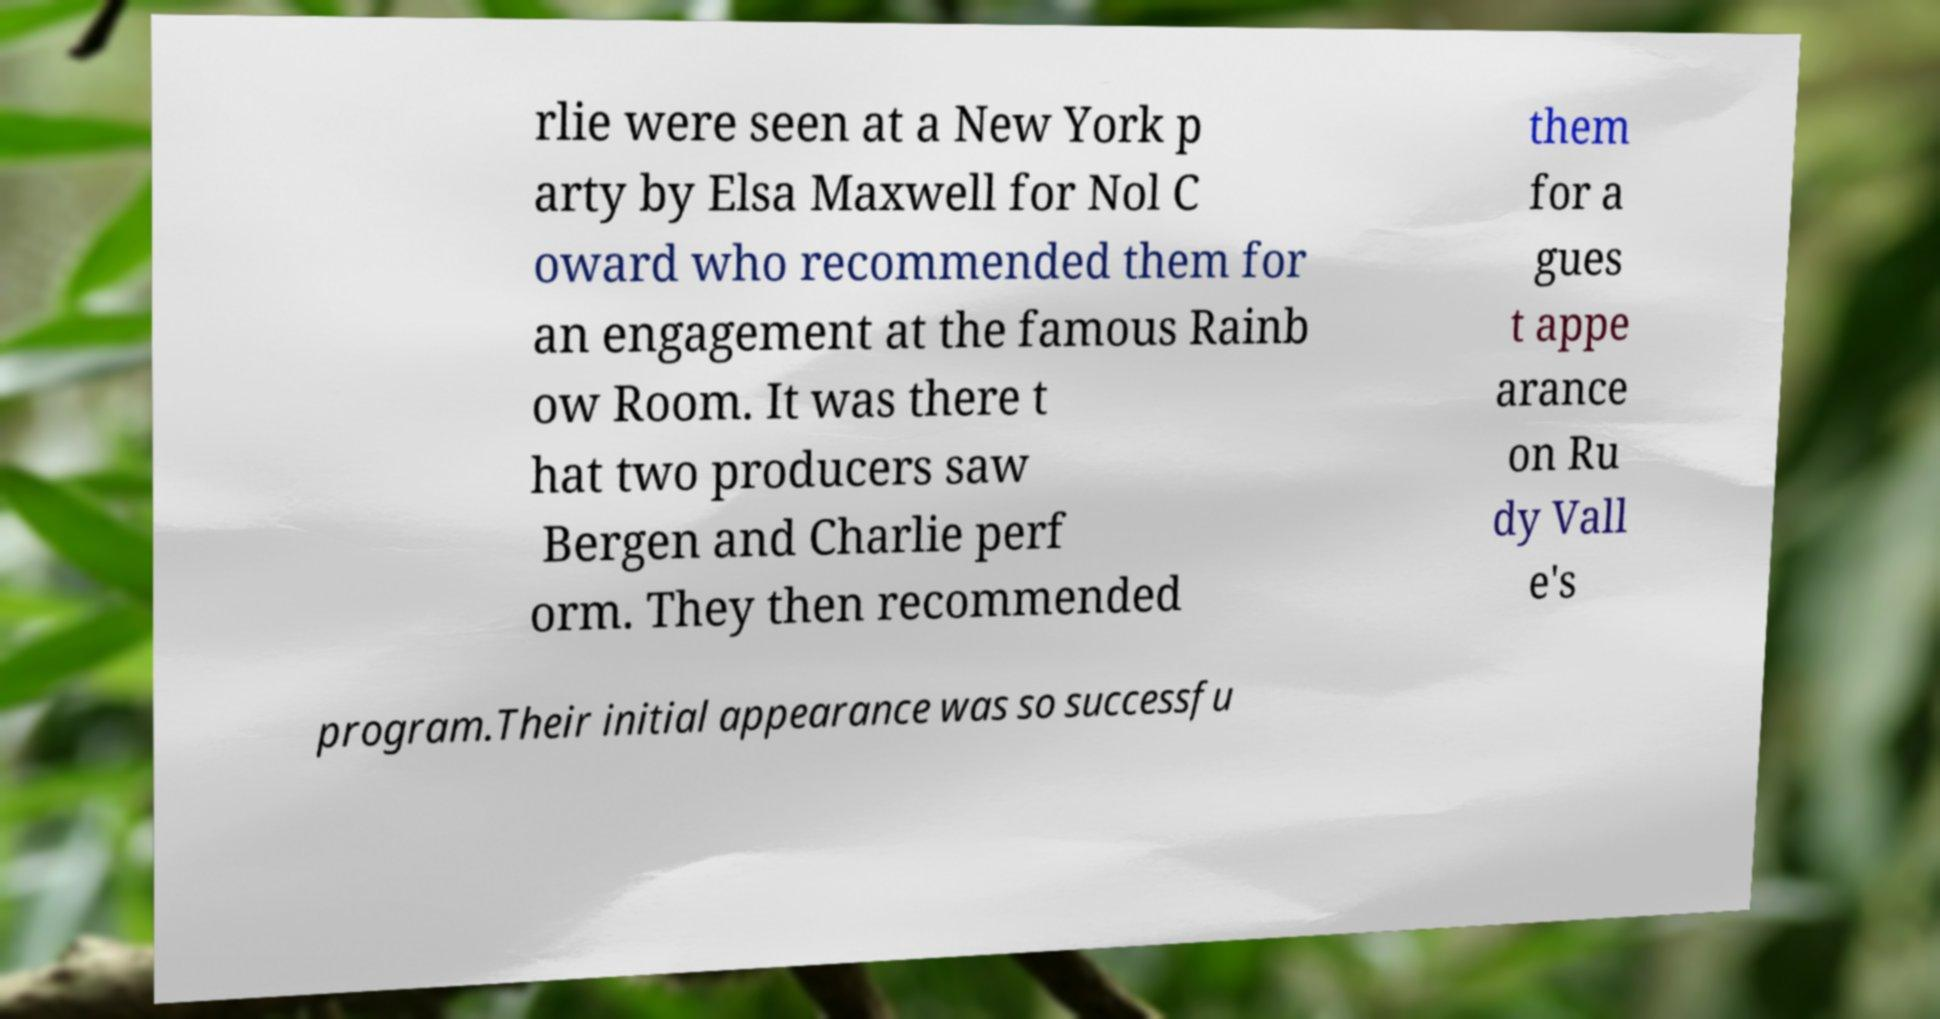Could you assist in decoding the text presented in this image and type it out clearly? rlie were seen at a New York p arty by Elsa Maxwell for Nol C oward who recommended them for an engagement at the famous Rainb ow Room. It was there t hat two producers saw Bergen and Charlie perf orm. They then recommended them for a gues t appe arance on Ru dy Vall e's program.Their initial appearance was so successfu 